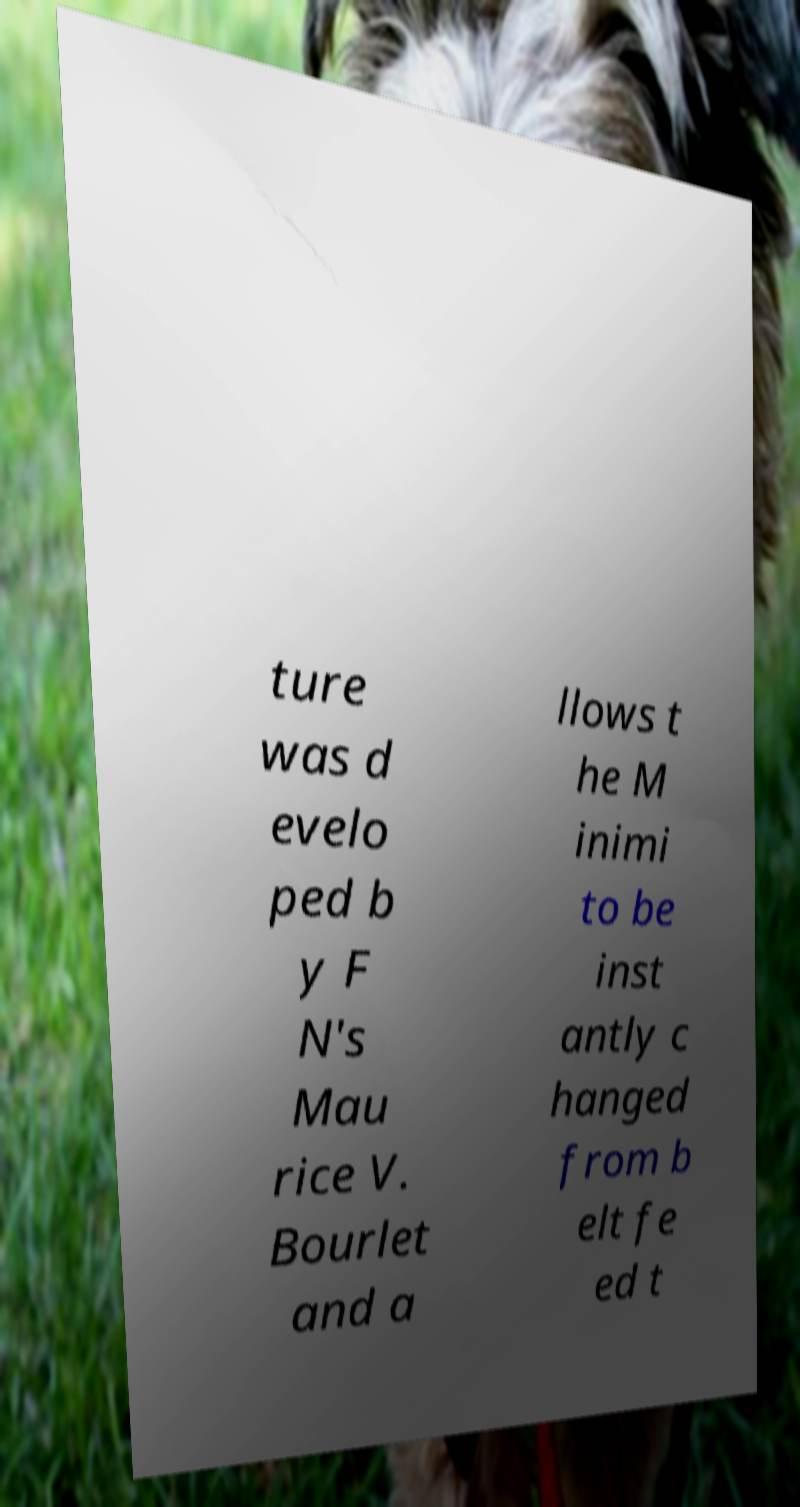I need the written content from this picture converted into text. Can you do that? ture was d evelo ped b y F N's Mau rice V. Bourlet and a llows t he M inimi to be inst antly c hanged from b elt fe ed t 